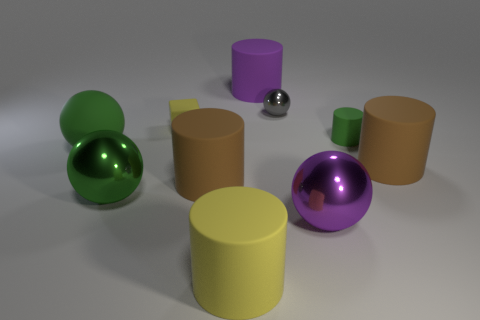What material is the purple thing that is the same shape as the small green object?
Make the answer very short. Rubber. Are there any tiny rubber cubes?
Provide a short and direct response. Yes. What shape is the tiny object that is made of the same material as the small cube?
Keep it short and to the point. Cylinder. What is the large purple object that is right of the purple matte cylinder made of?
Ensure brevity in your answer.  Metal. Do the small matte object to the right of the tiny gray metal thing and the large rubber sphere have the same color?
Offer a terse response. Yes. There is a brown thing that is on the left side of the green matte thing that is to the right of the green metal object; what size is it?
Offer a very short reply. Large. Is the number of big matte cylinders behind the big purple sphere greater than the number of purple shiny things?
Your answer should be very brief. Yes. Is the size of the brown thing that is to the left of the gray thing the same as the purple rubber cylinder?
Provide a short and direct response. Yes. What color is the matte cylinder that is behind the big green matte ball and on the right side of the purple matte cylinder?
Ensure brevity in your answer.  Green. The purple shiny thing that is the same size as the green metallic sphere is what shape?
Make the answer very short. Sphere. 